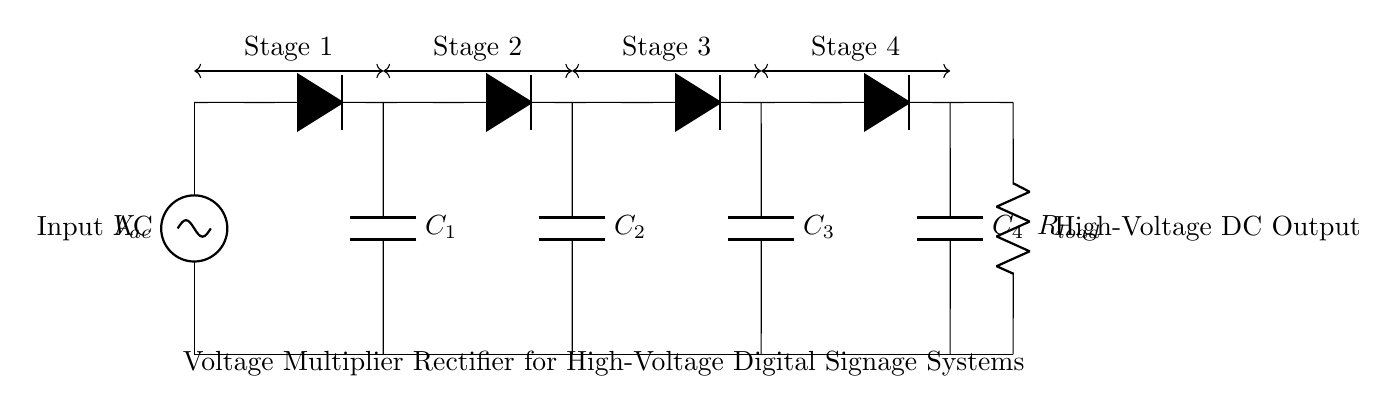What is the input type for this circuit? The input type is AC, indicated by the source labeled V_ac at the beginning of the circuit diagram.
Answer: AC How many stages does the voltage multiplier rectifier circuit have? The circuit has four stages, as shown by the four sets of diodes and capacitors connected in series and labeled as Stage 1, Stage 2, Stage 3, and Stage 4.
Answer: Four What is the role of the capacitors in this circuit? The capacitors (C1, C2, C3, C4) serve to store charge and smooth the output voltage by acting as filter components in the rectification process, contributing to voltage multiplication.
Answer: Store charge What is the load component at the end of the circuit? The load component is a resistor labeled R_load, which represents the load that the high-voltage DC output powers in the digital signage system.
Answer: Resistor What is the output type of this circuit? The output type is high-voltage DC, as indicated by the connection from the last capacitor stage to the output labeled as High-Voltage DC Output in the diagram.
Answer: High-Voltage DC How does this circuit achieve voltage multiplication? This circuit achieves voltage multiplication by connecting multiple stages of diodes and capacitors in series, allowing the output voltage to be a multiple of the input AC voltage as each stage effectively boosts the voltage by charging the capacitors through the diodes.
Answer: Multiple stages boost voltage 